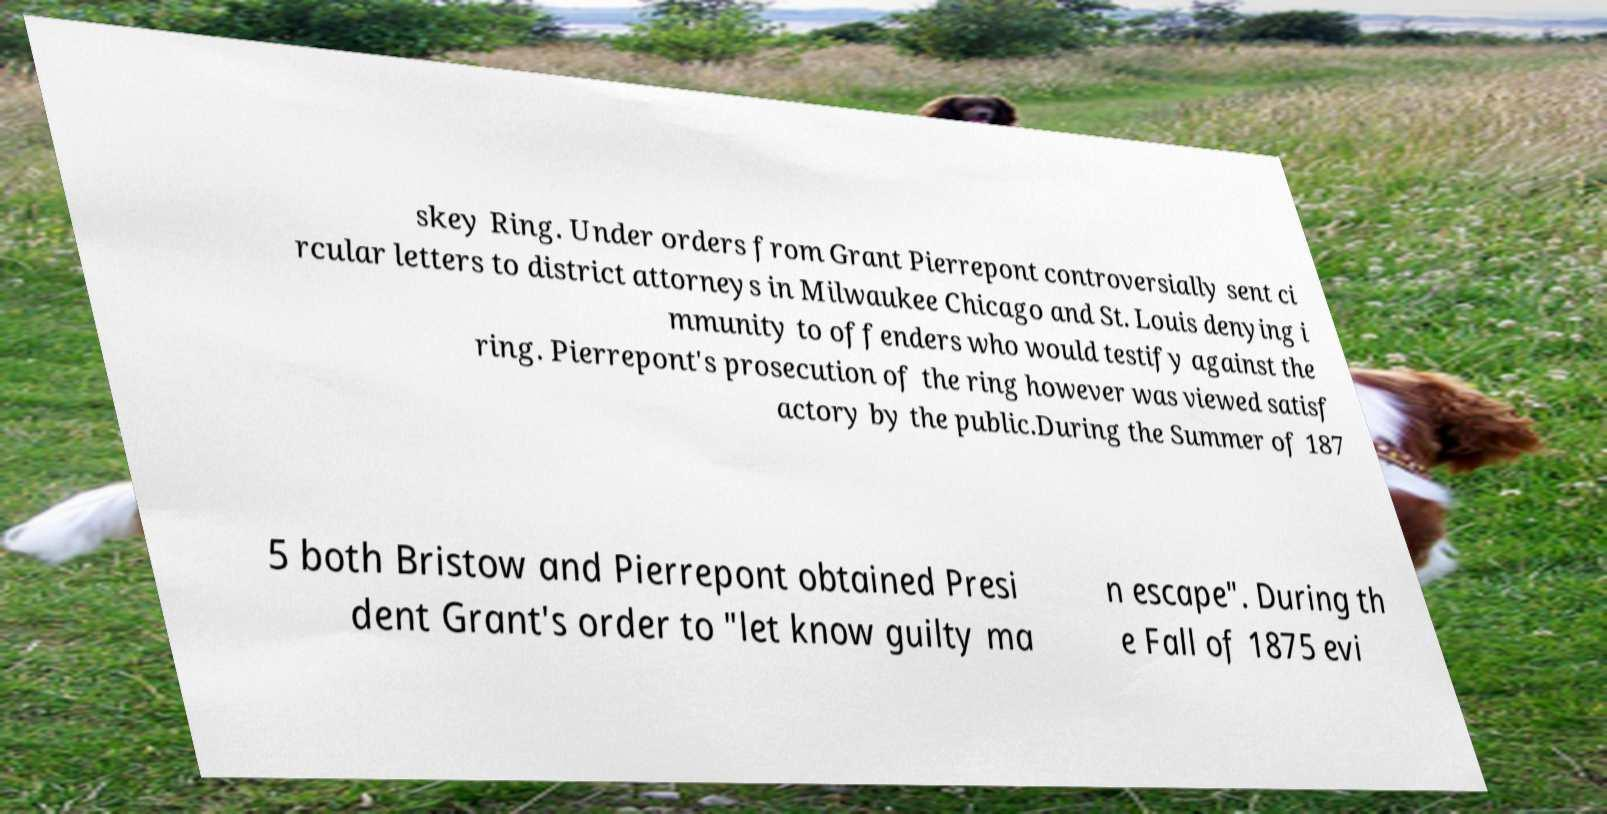Could you assist in decoding the text presented in this image and type it out clearly? skey Ring. Under orders from Grant Pierrepont controversially sent ci rcular letters to district attorneys in Milwaukee Chicago and St. Louis denying i mmunity to offenders who would testify against the ring. Pierrepont's prosecution of the ring however was viewed satisf actory by the public.During the Summer of 187 5 both Bristow and Pierrepont obtained Presi dent Grant's order to "let know guilty ma n escape". During th e Fall of 1875 evi 